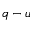Convert formula to latex. <formula><loc_0><loc_0><loc_500><loc_500>q - u</formula> 